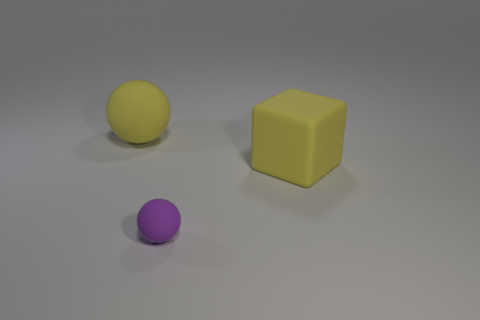Add 2 small yellow shiny objects. How many objects exist? 5 Subtract 1 balls. How many balls are left? 1 Subtract all yellow spheres. How many spheres are left? 1 Subtract all green balls. Subtract all gray cylinders. How many balls are left? 2 Subtract all blue spheres. How many purple blocks are left? 0 Subtract all small green rubber cubes. Subtract all yellow rubber blocks. How many objects are left? 2 Add 2 tiny things. How many tiny things are left? 3 Add 2 large balls. How many large balls exist? 3 Subtract 1 yellow balls. How many objects are left? 2 Subtract all spheres. How many objects are left? 1 